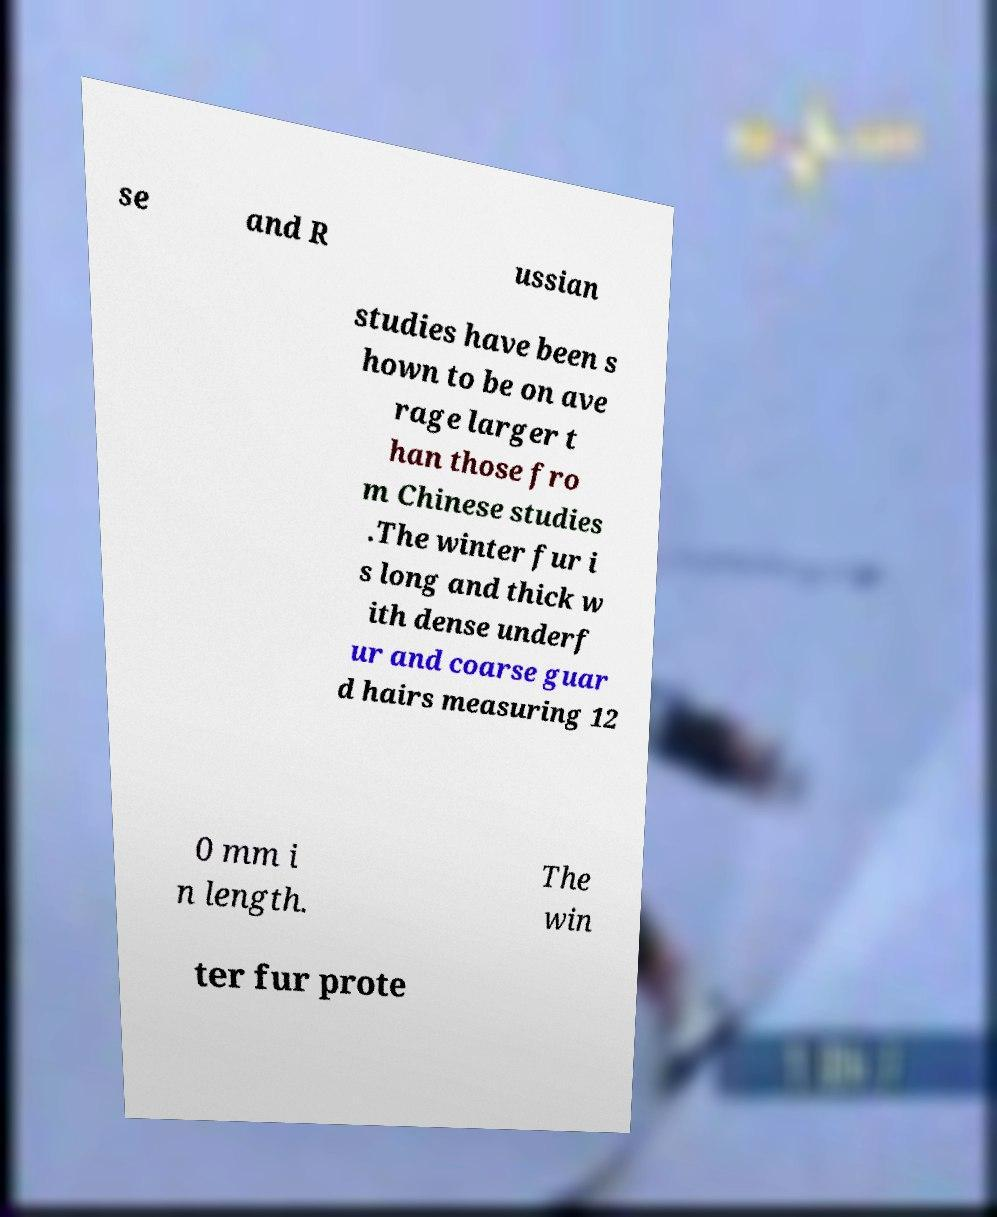Could you assist in decoding the text presented in this image and type it out clearly? se and R ussian studies have been s hown to be on ave rage larger t han those fro m Chinese studies .The winter fur i s long and thick w ith dense underf ur and coarse guar d hairs measuring 12 0 mm i n length. The win ter fur prote 